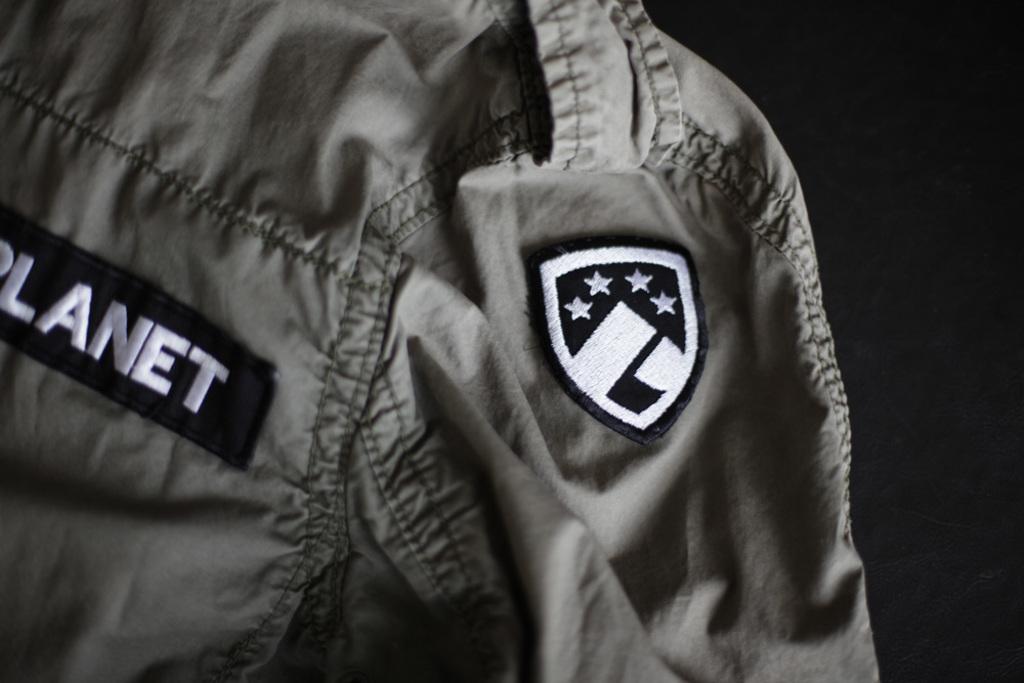What type of astronomical term is used on the person's tag?
Make the answer very short. Planet. What color is the word "planet" on his jacket?
Make the answer very short. White. 